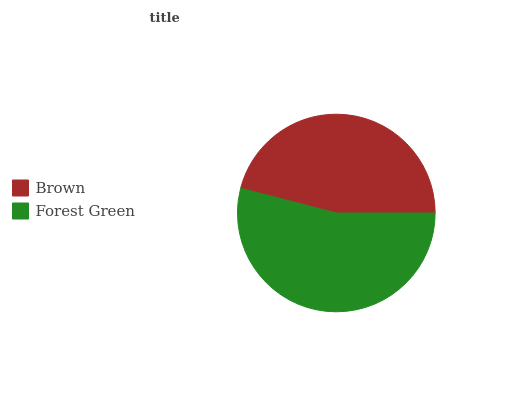Is Brown the minimum?
Answer yes or no. Yes. Is Forest Green the maximum?
Answer yes or no. Yes. Is Forest Green the minimum?
Answer yes or no. No. Is Forest Green greater than Brown?
Answer yes or no. Yes. Is Brown less than Forest Green?
Answer yes or no. Yes. Is Brown greater than Forest Green?
Answer yes or no. No. Is Forest Green less than Brown?
Answer yes or no. No. Is Forest Green the high median?
Answer yes or no. Yes. Is Brown the low median?
Answer yes or no. Yes. Is Brown the high median?
Answer yes or no. No. Is Forest Green the low median?
Answer yes or no. No. 